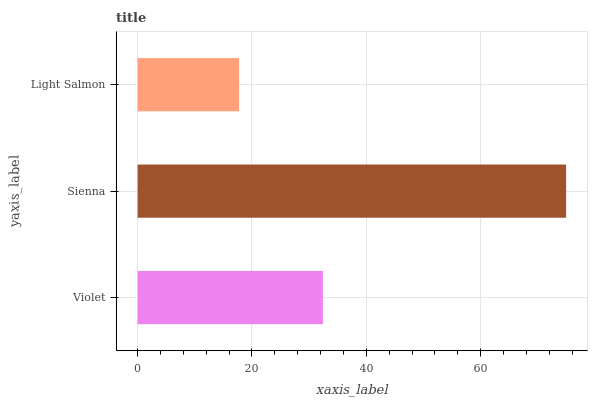Is Light Salmon the minimum?
Answer yes or no. Yes. Is Sienna the maximum?
Answer yes or no. Yes. Is Sienna the minimum?
Answer yes or no. No. Is Light Salmon the maximum?
Answer yes or no. No. Is Sienna greater than Light Salmon?
Answer yes or no. Yes. Is Light Salmon less than Sienna?
Answer yes or no. Yes. Is Light Salmon greater than Sienna?
Answer yes or no. No. Is Sienna less than Light Salmon?
Answer yes or no. No. Is Violet the high median?
Answer yes or no. Yes. Is Violet the low median?
Answer yes or no. Yes. Is Sienna the high median?
Answer yes or no. No. Is Sienna the low median?
Answer yes or no. No. 